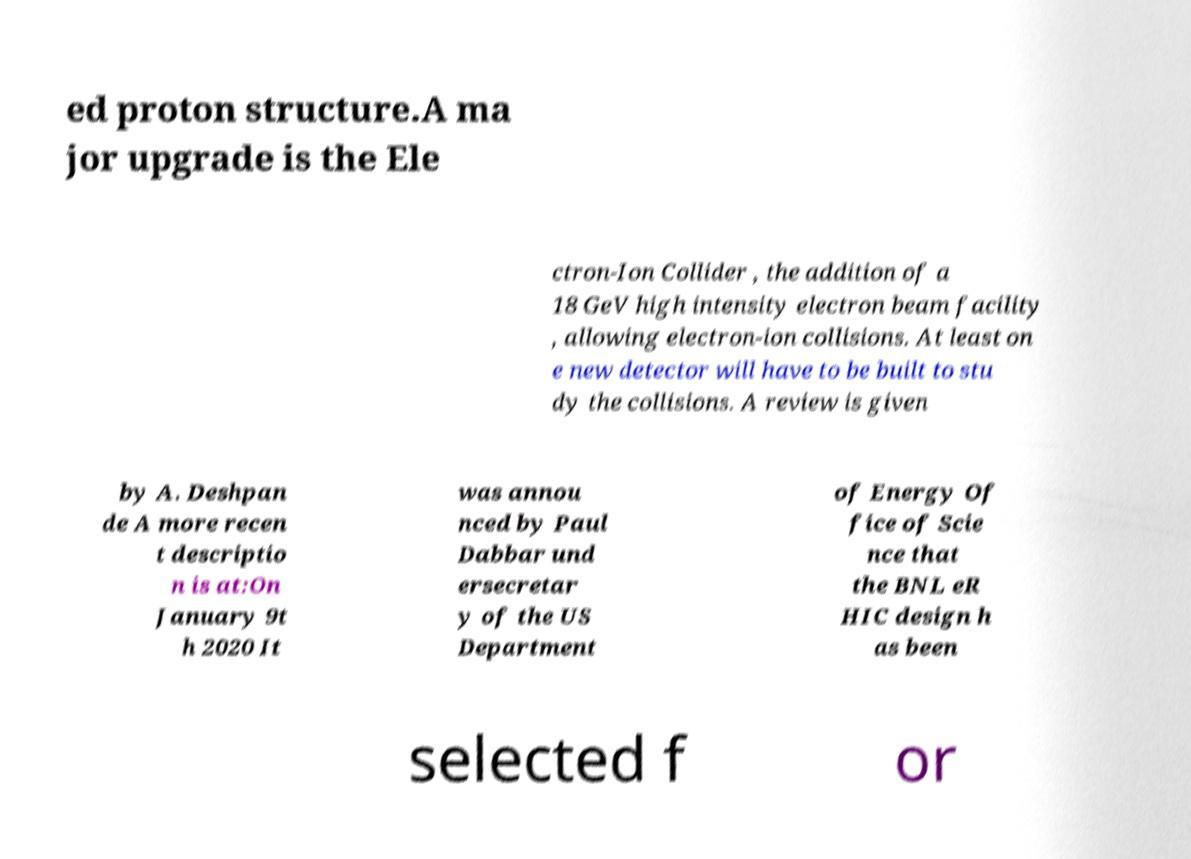Could you assist in decoding the text presented in this image and type it out clearly? ed proton structure.A ma jor upgrade is the Ele ctron-Ion Collider , the addition of a 18 GeV high intensity electron beam facility , allowing electron-ion collisions. At least on e new detector will have to be built to stu dy the collisions. A review is given by A. Deshpan de A more recen t descriptio n is at:On January 9t h 2020 It was annou nced by Paul Dabbar und ersecretar y of the US Department of Energy Of fice of Scie nce that the BNL eR HIC design h as been selected f or 